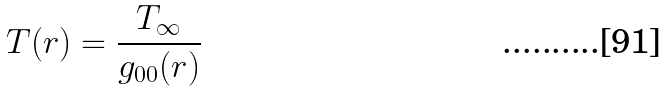<formula> <loc_0><loc_0><loc_500><loc_500>T ( r ) = \frac { T _ { \infty } } { g _ { 0 0 } ( r ) }</formula> 